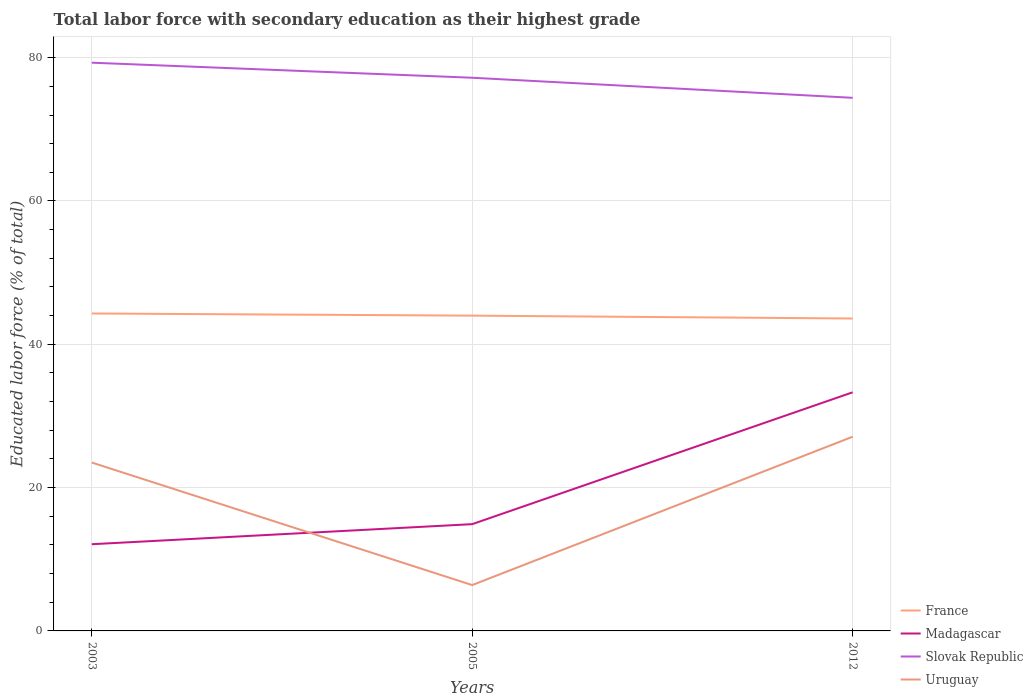Is the number of lines equal to the number of legend labels?
Make the answer very short. Yes. Across all years, what is the maximum percentage of total labor force with primary education in Slovak Republic?
Your answer should be compact. 74.4. In which year was the percentage of total labor force with primary education in Madagascar maximum?
Give a very brief answer. 2003. What is the total percentage of total labor force with primary education in Uruguay in the graph?
Keep it short and to the point. 17.1. What is the difference between the highest and the second highest percentage of total labor force with primary education in France?
Provide a succinct answer. 0.7. What is the difference between the highest and the lowest percentage of total labor force with primary education in Madagascar?
Ensure brevity in your answer.  1. Is the percentage of total labor force with primary education in Slovak Republic strictly greater than the percentage of total labor force with primary education in France over the years?
Offer a terse response. No. What is the difference between two consecutive major ticks on the Y-axis?
Provide a short and direct response. 20. Are the values on the major ticks of Y-axis written in scientific E-notation?
Make the answer very short. No. Does the graph contain any zero values?
Your answer should be very brief. No. Where does the legend appear in the graph?
Give a very brief answer. Bottom right. How many legend labels are there?
Make the answer very short. 4. What is the title of the graph?
Provide a short and direct response. Total labor force with secondary education as their highest grade. Does "Singapore" appear as one of the legend labels in the graph?
Your answer should be very brief. No. What is the label or title of the Y-axis?
Provide a short and direct response. Educated labor force (% of total). What is the Educated labor force (% of total) in France in 2003?
Make the answer very short. 44.3. What is the Educated labor force (% of total) in Madagascar in 2003?
Ensure brevity in your answer.  12.1. What is the Educated labor force (% of total) of Slovak Republic in 2003?
Give a very brief answer. 79.3. What is the Educated labor force (% of total) of Madagascar in 2005?
Offer a very short reply. 14.9. What is the Educated labor force (% of total) of Slovak Republic in 2005?
Offer a very short reply. 77.2. What is the Educated labor force (% of total) in Uruguay in 2005?
Make the answer very short. 6.4. What is the Educated labor force (% of total) of France in 2012?
Offer a very short reply. 43.6. What is the Educated labor force (% of total) of Madagascar in 2012?
Give a very brief answer. 33.3. What is the Educated labor force (% of total) in Slovak Republic in 2012?
Offer a terse response. 74.4. What is the Educated labor force (% of total) in Uruguay in 2012?
Your answer should be compact. 27.1. Across all years, what is the maximum Educated labor force (% of total) of France?
Your answer should be very brief. 44.3. Across all years, what is the maximum Educated labor force (% of total) in Madagascar?
Provide a short and direct response. 33.3. Across all years, what is the maximum Educated labor force (% of total) of Slovak Republic?
Offer a terse response. 79.3. Across all years, what is the maximum Educated labor force (% of total) in Uruguay?
Your answer should be compact. 27.1. Across all years, what is the minimum Educated labor force (% of total) in France?
Your answer should be very brief. 43.6. Across all years, what is the minimum Educated labor force (% of total) of Madagascar?
Your answer should be compact. 12.1. Across all years, what is the minimum Educated labor force (% of total) in Slovak Republic?
Offer a very short reply. 74.4. Across all years, what is the minimum Educated labor force (% of total) in Uruguay?
Provide a succinct answer. 6.4. What is the total Educated labor force (% of total) of France in the graph?
Your answer should be very brief. 131.9. What is the total Educated labor force (% of total) of Madagascar in the graph?
Your response must be concise. 60.3. What is the total Educated labor force (% of total) in Slovak Republic in the graph?
Provide a succinct answer. 230.9. What is the total Educated labor force (% of total) of Uruguay in the graph?
Offer a very short reply. 57. What is the difference between the Educated labor force (% of total) in France in 2003 and that in 2005?
Offer a very short reply. 0.3. What is the difference between the Educated labor force (% of total) in Slovak Republic in 2003 and that in 2005?
Keep it short and to the point. 2.1. What is the difference between the Educated labor force (% of total) of Madagascar in 2003 and that in 2012?
Make the answer very short. -21.2. What is the difference between the Educated labor force (% of total) of Uruguay in 2003 and that in 2012?
Offer a very short reply. -3.6. What is the difference between the Educated labor force (% of total) of Madagascar in 2005 and that in 2012?
Provide a short and direct response. -18.4. What is the difference between the Educated labor force (% of total) of Uruguay in 2005 and that in 2012?
Offer a very short reply. -20.7. What is the difference between the Educated labor force (% of total) of France in 2003 and the Educated labor force (% of total) of Madagascar in 2005?
Provide a succinct answer. 29.4. What is the difference between the Educated labor force (% of total) in France in 2003 and the Educated labor force (% of total) in Slovak Republic in 2005?
Provide a succinct answer. -32.9. What is the difference between the Educated labor force (% of total) in France in 2003 and the Educated labor force (% of total) in Uruguay in 2005?
Make the answer very short. 37.9. What is the difference between the Educated labor force (% of total) of Madagascar in 2003 and the Educated labor force (% of total) of Slovak Republic in 2005?
Keep it short and to the point. -65.1. What is the difference between the Educated labor force (% of total) in Madagascar in 2003 and the Educated labor force (% of total) in Uruguay in 2005?
Ensure brevity in your answer.  5.7. What is the difference between the Educated labor force (% of total) in Slovak Republic in 2003 and the Educated labor force (% of total) in Uruguay in 2005?
Provide a short and direct response. 72.9. What is the difference between the Educated labor force (% of total) in France in 2003 and the Educated labor force (% of total) in Slovak Republic in 2012?
Provide a succinct answer. -30.1. What is the difference between the Educated labor force (% of total) in Madagascar in 2003 and the Educated labor force (% of total) in Slovak Republic in 2012?
Ensure brevity in your answer.  -62.3. What is the difference between the Educated labor force (% of total) of Madagascar in 2003 and the Educated labor force (% of total) of Uruguay in 2012?
Provide a succinct answer. -15. What is the difference between the Educated labor force (% of total) of Slovak Republic in 2003 and the Educated labor force (% of total) of Uruguay in 2012?
Make the answer very short. 52.2. What is the difference between the Educated labor force (% of total) in France in 2005 and the Educated labor force (% of total) in Slovak Republic in 2012?
Offer a very short reply. -30.4. What is the difference between the Educated labor force (% of total) of Madagascar in 2005 and the Educated labor force (% of total) of Slovak Republic in 2012?
Your answer should be compact. -59.5. What is the difference between the Educated labor force (% of total) of Madagascar in 2005 and the Educated labor force (% of total) of Uruguay in 2012?
Your answer should be very brief. -12.2. What is the difference between the Educated labor force (% of total) of Slovak Republic in 2005 and the Educated labor force (% of total) of Uruguay in 2012?
Give a very brief answer. 50.1. What is the average Educated labor force (% of total) in France per year?
Provide a succinct answer. 43.97. What is the average Educated labor force (% of total) of Madagascar per year?
Provide a short and direct response. 20.1. What is the average Educated labor force (% of total) of Slovak Republic per year?
Offer a terse response. 76.97. What is the average Educated labor force (% of total) of Uruguay per year?
Give a very brief answer. 19. In the year 2003, what is the difference between the Educated labor force (% of total) in France and Educated labor force (% of total) in Madagascar?
Your answer should be very brief. 32.2. In the year 2003, what is the difference between the Educated labor force (% of total) in France and Educated labor force (% of total) in Slovak Republic?
Your answer should be very brief. -35. In the year 2003, what is the difference between the Educated labor force (% of total) in France and Educated labor force (% of total) in Uruguay?
Your answer should be compact. 20.8. In the year 2003, what is the difference between the Educated labor force (% of total) in Madagascar and Educated labor force (% of total) in Slovak Republic?
Give a very brief answer. -67.2. In the year 2003, what is the difference between the Educated labor force (% of total) of Madagascar and Educated labor force (% of total) of Uruguay?
Your answer should be compact. -11.4. In the year 2003, what is the difference between the Educated labor force (% of total) in Slovak Republic and Educated labor force (% of total) in Uruguay?
Your answer should be very brief. 55.8. In the year 2005, what is the difference between the Educated labor force (% of total) in France and Educated labor force (% of total) in Madagascar?
Make the answer very short. 29.1. In the year 2005, what is the difference between the Educated labor force (% of total) of France and Educated labor force (% of total) of Slovak Republic?
Your answer should be compact. -33.2. In the year 2005, what is the difference between the Educated labor force (% of total) in France and Educated labor force (% of total) in Uruguay?
Keep it short and to the point. 37.6. In the year 2005, what is the difference between the Educated labor force (% of total) of Madagascar and Educated labor force (% of total) of Slovak Republic?
Your answer should be very brief. -62.3. In the year 2005, what is the difference between the Educated labor force (% of total) of Madagascar and Educated labor force (% of total) of Uruguay?
Ensure brevity in your answer.  8.5. In the year 2005, what is the difference between the Educated labor force (% of total) in Slovak Republic and Educated labor force (% of total) in Uruguay?
Your answer should be very brief. 70.8. In the year 2012, what is the difference between the Educated labor force (% of total) in France and Educated labor force (% of total) in Madagascar?
Your answer should be very brief. 10.3. In the year 2012, what is the difference between the Educated labor force (% of total) of France and Educated labor force (% of total) of Slovak Republic?
Provide a short and direct response. -30.8. In the year 2012, what is the difference between the Educated labor force (% of total) of France and Educated labor force (% of total) of Uruguay?
Offer a terse response. 16.5. In the year 2012, what is the difference between the Educated labor force (% of total) of Madagascar and Educated labor force (% of total) of Slovak Republic?
Ensure brevity in your answer.  -41.1. In the year 2012, what is the difference between the Educated labor force (% of total) in Madagascar and Educated labor force (% of total) in Uruguay?
Offer a terse response. 6.2. In the year 2012, what is the difference between the Educated labor force (% of total) of Slovak Republic and Educated labor force (% of total) of Uruguay?
Give a very brief answer. 47.3. What is the ratio of the Educated labor force (% of total) of France in 2003 to that in 2005?
Offer a terse response. 1.01. What is the ratio of the Educated labor force (% of total) in Madagascar in 2003 to that in 2005?
Your answer should be compact. 0.81. What is the ratio of the Educated labor force (% of total) of Slovak Republic in 2003 to that in 2005?
Your answer should be very brief. 1.03. What is the ratio of the Educated labor force (% of total) of Uruguay in 2003 to that in 2005?
Make the answer very short. 3.67. What is the ratio of the Educated labor force (% of total) in France in 2003 to that in 2012?
Your response must be concise. 1.02. What is the ratio of the Educated labor force (% of total) of Madagascar in 2003 to that in 2012?
Provide a short and direct response. 0.36. What is the ratio of the Educated labor force (% of total) of Slovak Republic in 2003 to that in 2012?
Your answer should be very brief. 1.07. What is the ratio of the Educated labor force (% of total) in Uruguay in 2003 to that in 2012?
Provide a succinct answer. 0.87. What is the ratio of the Educated labor force (% of total) of France in 2005 to that in 2012?
Keep it short and to the point. 1.01. What is the ratio of the Educated labor force (% of total) of Madagascar in 2005 to that in 2012?
Give a very brief answer. 0.45. What is the ratio of the Educated labor force (% of total) in Slovak Republic in 2005 to that in 2012?
Provide a short and direct response. 1.04. What is the ratio of the Educated labor force (% of total) in Uruguay in 2005 to that in 2012?
Provide a succinct answer. 0.24. What is the difference between the highest and the second highest Educated labor force (% of total) of Madagascar?
Ensure brevity in your answer.  18.4. What is the difference between the highest and the second highest Educated labor force (% of total) in Slovak Republic?
Your response must be concise. 2.1. What is the difference between the highest and the second highest Educated labor force (% of total) in Uruguay?
Your response must be concise. 3.6. What is the difference between the highest and the lowest Educated labor force (% of total) in France?
Your response must be concise. 0.7. What is the difference between the highest and the lowest Educated labor force (% of total) in Madagascar?
Your answer should be very brief. 21.2. What is the difference between the highest and the lowest Educated labor force (% of total) of Slovak Republic?
Your answer should be compact. 4.9. What is the difference between the highest and the lowest Educated labor force (% of total) in Uruguay?
Your response must be concise. 20.7. 